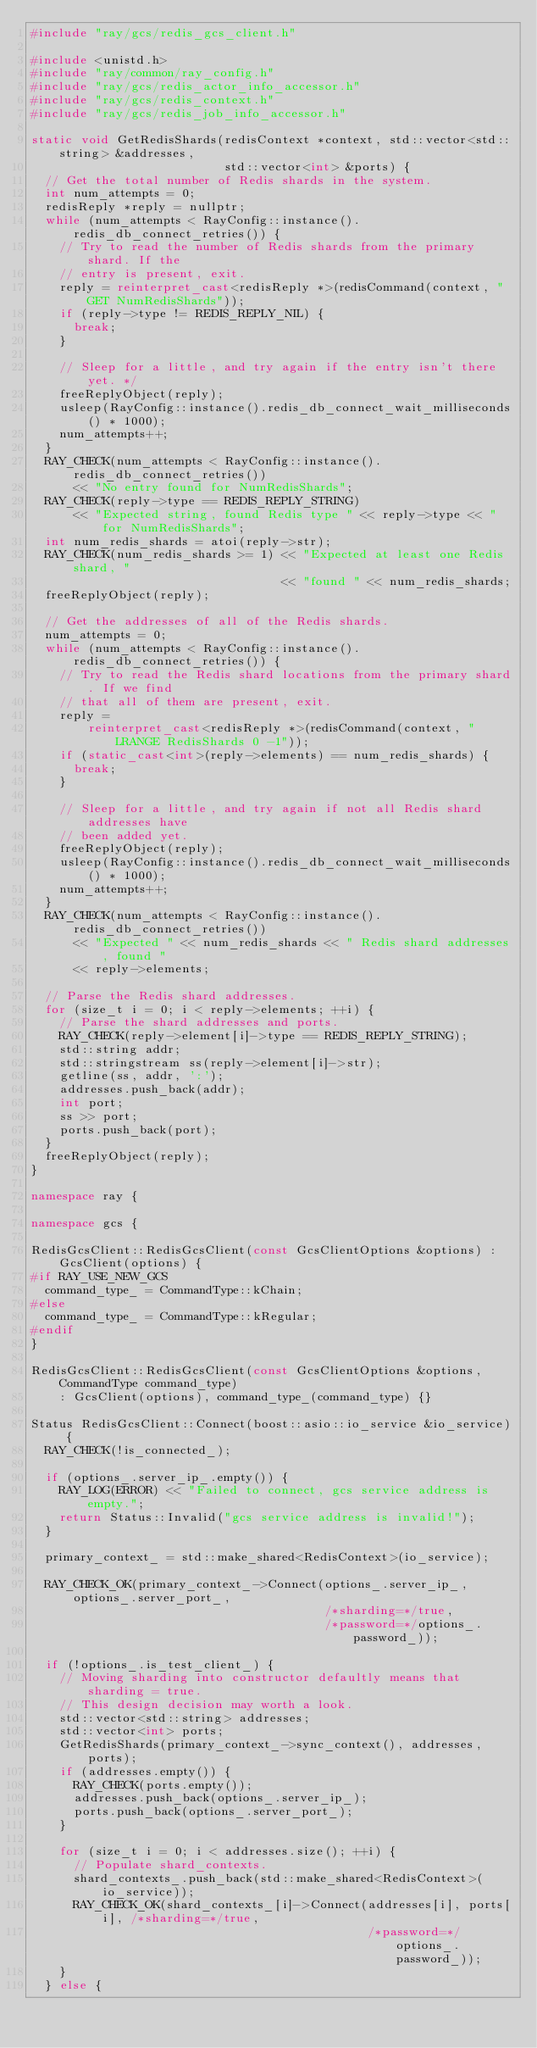Convert code to text. <code><loc_0><loc_0><loc_500><loc_500><_C++_>#include "ray/gcs/redis_gcs_client.h"

#include <unistd.h>
#include "ray/common/ray_config.h"
#include "ray/gcs/redis_actor_info_accessor.h"
#include "ray/gcs/redis_context.h"
#include "ray/gcs/redis_job_info_accessor.h"

static void GetRedisShards(redisContext *context, std::vector<std::string> &addresses,
                           std::vector<int> &ports) {
  // Get the total number of Redis shards in the system.
  int num_attempts = 0;
  redisReply *reply = nullptr;
  while (num_attempts < RayConfig::instance().redis_db_connect_retries()) {
    // Try to read the number of Redis shards from the primary shard. If the
    // entry is present, exit.
    reply = reinterpret_cast<redisReply *>(redisCommand(context, "GET NumRedisShards"));
    if (reply->type != REDIS_REPLY_NIL) {
      break;
    }

    // Sleep for a little, and try again if the entry isn't there yet. */
    freeReplyObject(reply);
    usleep(RayConfig::instance().redis_db_connect_wait_milliseconds() * 1000);
    num_attempts++;
  }
  RAY_CHECK(num_attempts < RayConfig::instance().redis_db_connect_retries())
      << "No entry found for NumRedisShards";
  RAY_CHECK(reply->type == REDIS_REPLY_STRING)
      << "Expected string, found Redis type " << reply->type << " for NumRedisShards";
  int num_redis_shards = atoi(reply->str);
  RAY_CHECK(num_redis_shards >= 1) << "Expected at least one Redis shard, "
                                   << "found " << num_redis_shards;
  freeReplyObject(reply);

  // Get the addresses of all of the Redis shards.
  num_attempts = 0;
  while (num_attempts < RayConfig::instance().redis_db_connect_retries()) {
    // Try to read the Redis shard locations from the primary shard. If we find
    // that all of them are present, exit.
    reply =
        reinterpret_cast<redisReply *>(redisCommand(context, "LRANGE RedisShards 0 -1"));
    if (static_cast<int>(reply->elements) == num_redis_shards) {
      break;
    }

    // Sleep for a little, and try again if not all Redis shard addresses have
    // been added yet.
    freeReplyObject(reply);
    usleep(RayConfig::instance().redis_db_connect_wait_milliseconds() * 1000);
    num_attempts++;
  }
  RAY_CHECK(num_attempts < RayConfig::instance().redis_db_connect_retries())
      << "Expected " << num_redis_shards << " Redis shard addresses, found "
      << reply->elements;

  // Parse the Redis shard addresses.
  for (size_t i = 0; i < reply->elements; ++i) {
    // Parse the shard addresses and ports.
    RAY_CHECK(reply->element[i]->type == REDIS_REPLY_STRING);
    std::string addr;
    std::stringstream ss(reply->element[i]->str);
    getline(ss, addr, ':');
    addresses.push_back(addr);
    int port;
    ss >> port;
    ports.push_back(port);
  }
  freeReplyObject(reply);
}

namespace ray {

namespace gcs {

RedisGcsClient::RedisGcsClient(const GcsClientOptions &options) : GcsClient(options) {
#if RAY_USE_NEW_GCS
  command_type_ = CommandType::kChain;
#else
  command_type_ = CommandType::kRegular;
#endif
}

RedisGcsClient::RedisGcsClient(const GcsClientOptions &options, CommandType command_type)
    : GcsClient(options), command_type_(command_type) {}

Status RedisGcsClient::Connect(boost::asio::io_service &io_service) {
  RAY_CHECK(!is_connected_);

  if (options_.server_ip_.empty()) {
    RAY_LOG(ERROR) << "Failed to connect, gcs service address is empty.";
    return Status::Invalid("gcs service address is invalid!");
  }

  primary_context_ = std::make_shared<RedisContext>(io_service);

  RAY_CHECK_OK(primary_context_->Connect(options_.server_ip_, options_.server_port_,
                                         /*sharding=*/true,
                                         /*password=*/options_.password_));

  if (!options_.is_test_client_) {
    // Moving sharding into constructor defaultly means that sharding = true.
    // This design decision may worth a look.
    std::vector<std::string> addresses;
    std::vector<int> ports;
    GetRedisShards(primary_context_->sync_context(), addresses, ports);
    if (addresses.empty()) {
      RAY_CHECK(ports.empty());
      addresses.push_back(options_.server_ip_);
      ports.push_back(options_.server_port_);
    }

    for (size_t i = 0; i < addresses.size(); ++i) {
      // Populate shard_contexts.
      shard_contexts_.push_back(std::make_shared<RedisContext>(io_service));
      RAY_CHECK_OK(shard_contexts_[i]->Connect(addresses[i], ports[i], /*sharding=*/true,
                                               /*password=*/options_.password_));
    }
  } else {</code> 